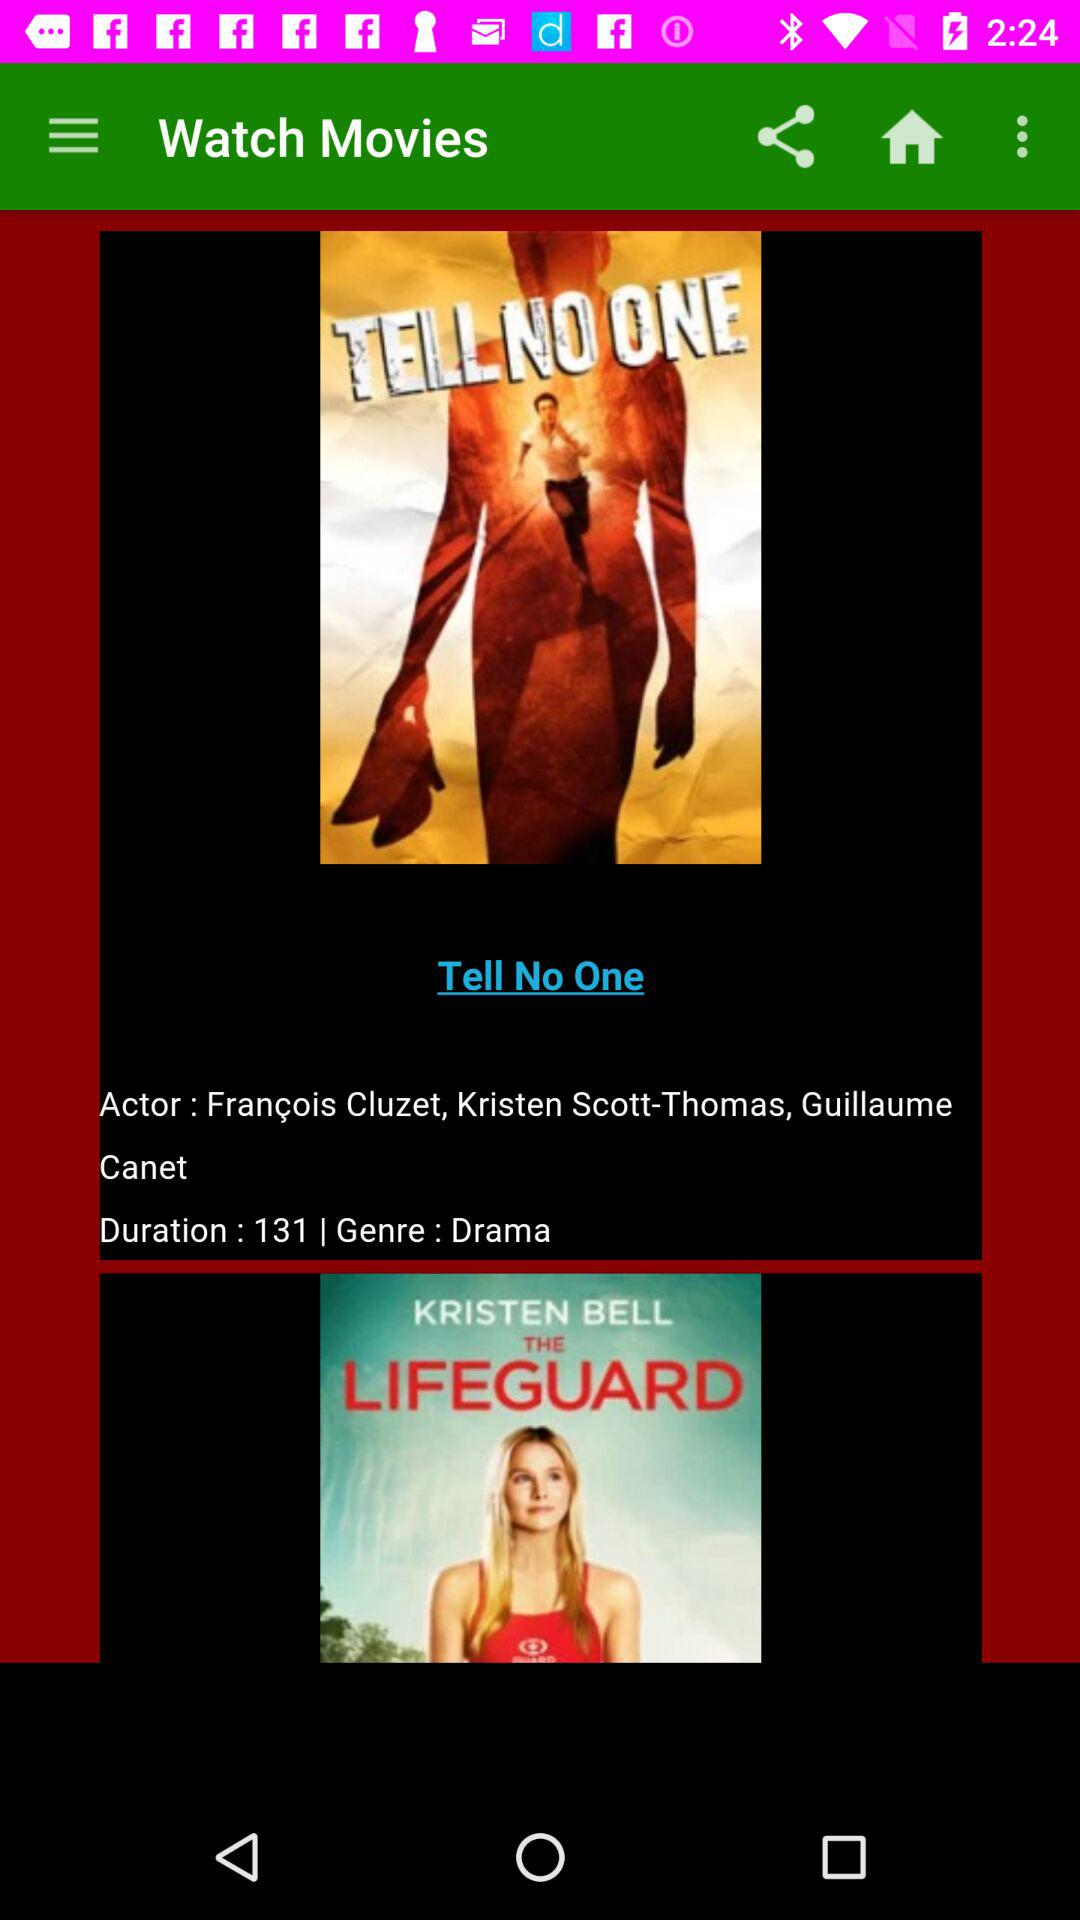What is the actor's name in the movie The Lifeguard? The actor's name is Kristen Bell. 